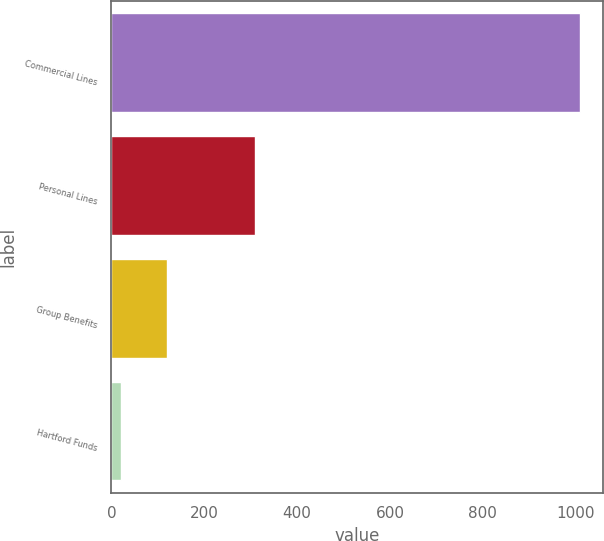<chart> <loc_0><loc_0><loc_500><loc_500><bar_chart><fcel>Commercial Lines<fcel>Personal Lines<fcel>Group Benefits<fcel>Hartford Funds<nl><fcel>1009<fcel>309<fcel>119.8<fcel>21<nl></chart> 